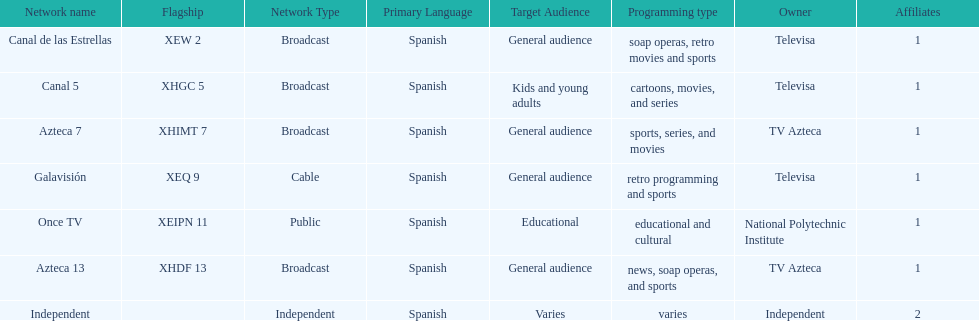Who is the only network owner listed in a consecutive order in the chart? Televisa. 